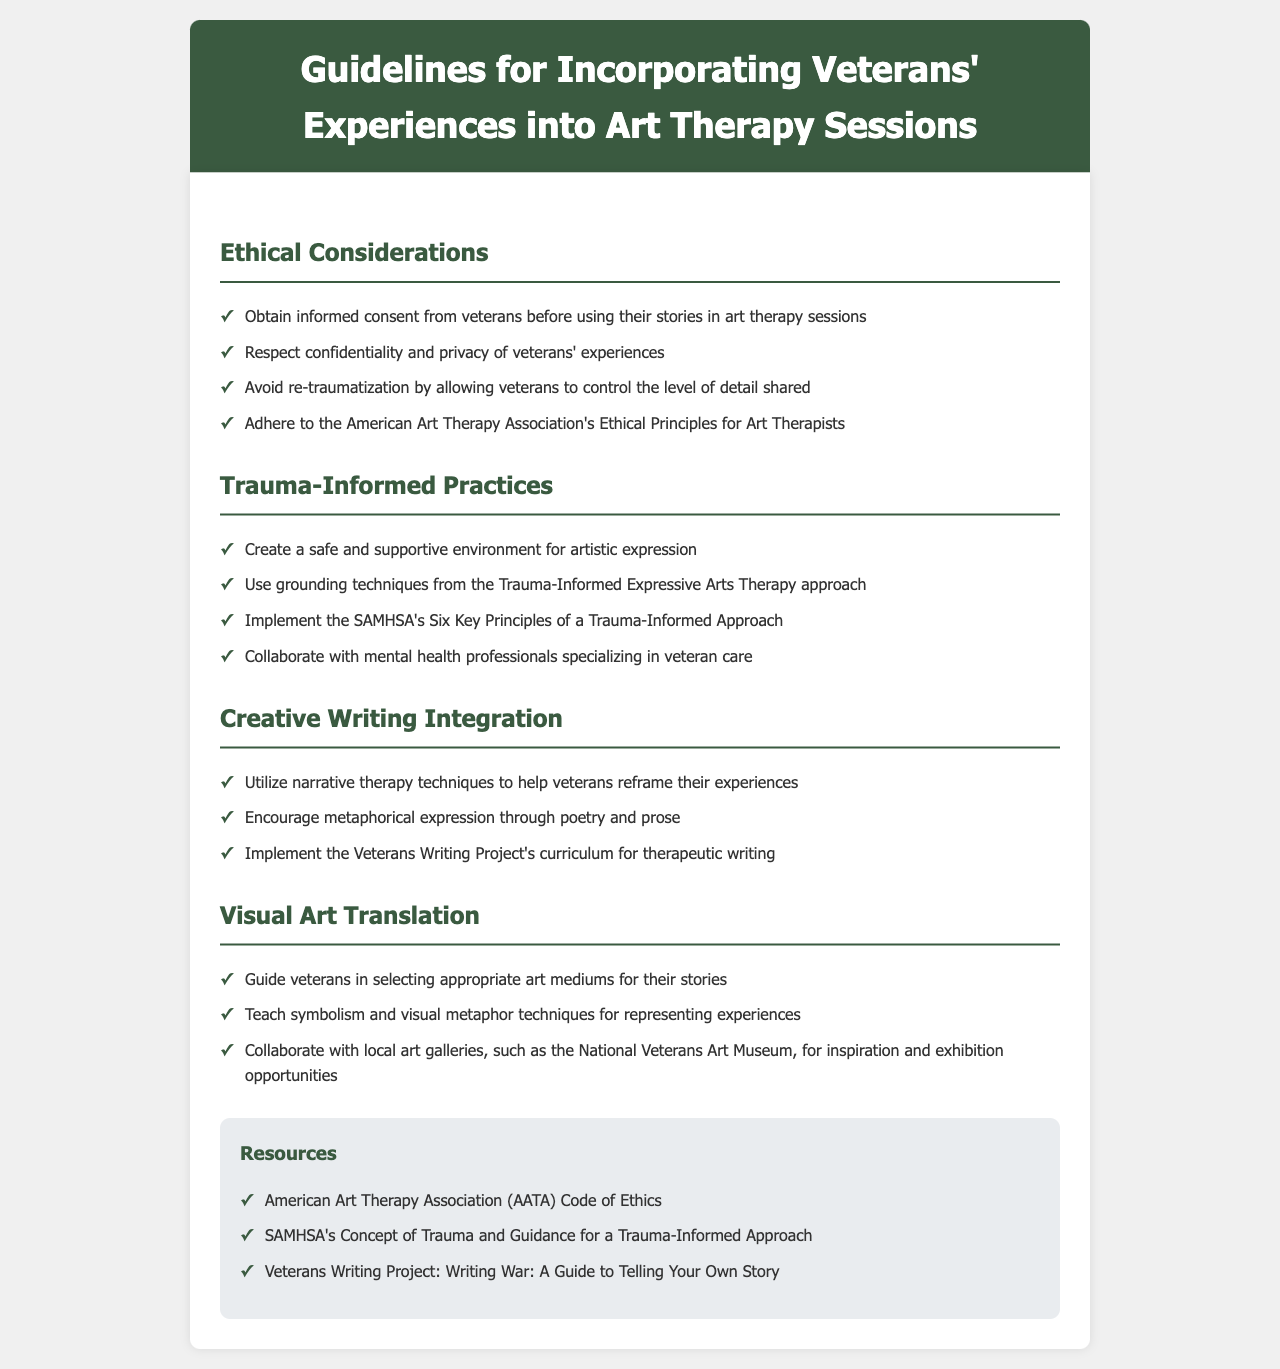What are the ethical principles to adhere to? The document mentions adhering to the American Art Therapy Association's Ethical Principles for Art Therapists as an ethical consideration.
Answer: American Art Therapy Association's Ethical Principles for Art Therapists What is the first principle of trauma-informed practices? The first principle under trauma-informed practices is to create a safe and supportive environment for artistic expression.
Answer: Create a safe and supportive environment for artistic expression What therapy techniques help veterans reframe their experiences? The document states that narrative therapy techniques are utilized to help veterans reframe their experiences.
Answer: Narrative therapy techniques How many key principles of a trauma-informed approach are mentioned? The document refers to SAMHSA's Six Key Principles of a Trauma-Informed Approach, indicating there are six principles.
Answer: Six Which project provides a guide for therapeutic writing? The document mentions the Veterans Writing Project's curriculum for therapeutic writing as a valuable resource.
Answer: Veterans Writing Project's curriculum What should veterans control to avoid re-traumatization? The document emphasizes that veterans should control the level of detail shared to avoid re-traumatization.
Answer: Level of detail shared What type of art is encouraged in collaboration with local galleries? The document encourages collaboration with local art galleries for inspiration and exhibition opportunities targeted at visual art translation.
Answer: Visual art What is one grounding technique mentioned? The document suggests using grounding techniques from the Trauma-Informed Expressive Arts Therapy approach as one of the practices.
Answer: Grounding techniques Which organization’s Code of Ethics is mentioned as a resource? The American Art Therapy Association's Code of Ethics is cited as a resource in the document.
Answer: American Art Therapy Association (AATA) Code of Ethics 